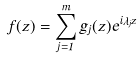<formula> <loc_0><loc_0><loc_500><loc_500>f ( z ) = \sum _ { j = 1 } ^ { m } g _ { j } ( z ) e ^ { i \lambda _ { j } z }</formula> 